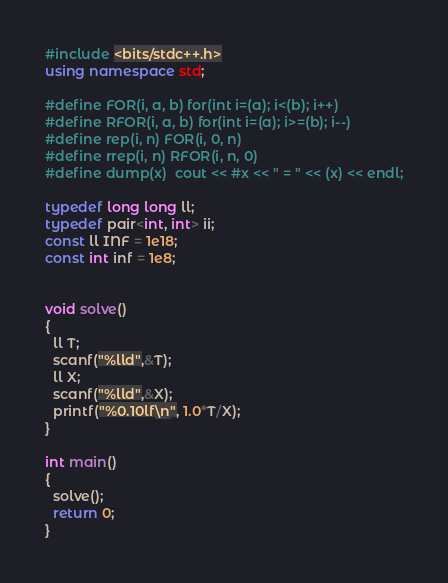<code> <loc_0><loc_0><loc_500><loc_500><_C++_>#include <bits/stdc++.h>
using namespace std;

#define FOR(i, a, b) for(int i=(a); i<(b); i++)
#define RFOR(i, a, b) for(int i=(a); i>=(b); i--)
#define rep(i, n) FOR(i, 0, n)
#define rrep(i, n) RFOR(i, n, 0)
#define dump(x)  cout << #x << " = " << (x) << endl;

typedef long long ll;
typedef pair<int, int> ii;
const ll INF = 1e18;
const int inf = 1e8;


void solve()
{
  ll T;
  scanf("%lld",&T);
  ll X;
  scanf("%lld",&X);
  printf("%0.10lf\n", 1.0*T/X);
}

int main()
{
  solve();
  return 0;
}
</code> 